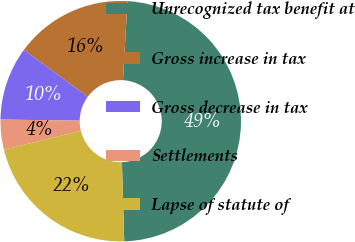<chart> <loc_0><loc_0><loc_500><loc_500><pie_chart><fcel>Unrecognized tax benefit at<fcel>Gross increase in tax<fcel>Gross decrease in tax<fcel>Settlements<fcel>Lapse of statute of<nl><fcel>48.65%<fcel>15.78%<fcel>9.9%<fcel>4.02%<fcel>21.66%<nl></chart> 